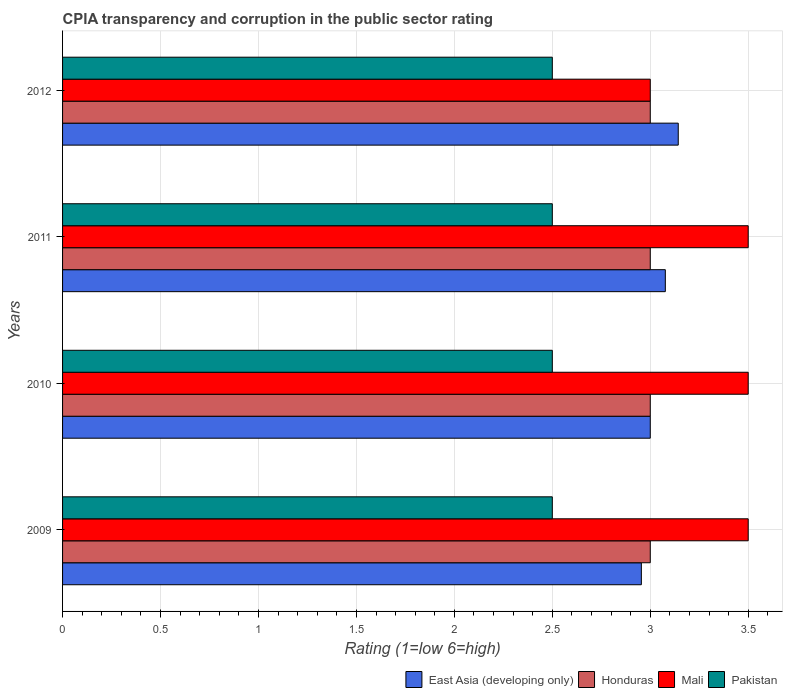How many different coloured bars are there?
Give a very brief answer. 4. Are the number of bars per tick equal to the number of legend labels?
Your response must be concise. Yes. Are the number of bars on each tick of the Y-axis equal?
Your answer should be compact. Yes. In how many cases, is the number of bars for a given year not equal to the number of legend labels?
Provide a succinct answer. 0. Across all years, what is the minimum CPIA rating in East Asia (developing only)?
Offer a terse response. 2.95. What is the difference between the CPIA rating in Honduras in 2010 and that in 2011?
Offer a very short reply. 0. What is the average CPIA rating in Mali per year?
Offer a terse response. 3.38. In how many years, is the CPIA rating in Mali greater than 0.30000000000000004 ?
Keep it short and to the point. 4. What is the ratio of the CPIA rating in Honduras in 2009 to that in 2012?
Your answer should be compact. 1. Is the difference between the CPIA rating in Pakistan in 2009 and 2011 greater than the difference between the CPIA rating in Mali in 2009 and 2011?
Provide a short and direct response. No. What is the difference between the highest and the second highest CPIA rating in Mali?
Provide a short and direct response. 0. In how many years, is the CPIA rating in East Asia (developing only) greater than the average CPIA rating in East Asia (developing only) taken over all years?
Provide a succinct answer. 2. What does the 2nd bar from the top in 2012 represents?
Make the answer very short. Mali. What does the 4th bar from the bottom in 2012 represents?
Keep it short and to the point. Pakistan. How many years are there in the graph?
Keep it short and to the point. 4. Does the graph contain any zero values?
Provide a succinct answer. No. How many legend labels are there?
Provide a short and direct response. 4. How are the legend labels stacked?
Your answer should be very brief. Horizontal. What is the title of the graph?
Give a very brief answer. CPIA transparency and corruption in the public sector rating. What is the label or title of the X-axis?
Provide a succinct answer. Rating (1=low 6=high). What is the Rating (1=low 6=high) in East Asia (developing only) in 2009?
Offer a very short reply. 2.95. What is the Rating (1=low 6=high) in Mali in 2009?
Offer a very short reply. 3.5. What is the Rating (1=low 6=high) of Pakistan in 2009?
Make the answer very short. 2.5. What is the Rating (1=low 6=high) in East Asia (developing only) in 2010?
Give a very brief answer. 3. What is the Rating (1=low 6=high) in Honduras in 2010?
Keep it short and to the point. 3. What is the Rating (1=low 6=high) in Mali in 2010?
Provide a succinct answer. 3.5. What is the Rating (1=low 6=high) in Pakistan in 2010?
Offer a terse response. 2.5. What is the Rating (1=low 6=high) of East Asia (developing only) in 2011?
Offer a terse response. 3.08. What is the Rating (1=low 6=high) of Honduras in 2011?
Ensure brevity in your answer.  3. What is the Rating (1=low 6=high) in Mali in 2011?
Your answer should be compact. 3.5. What is the Rating (1=low 6=high) of East Asia (developing only) in 2012?
Keep it short and to the point. 3.14. Across all years, what is the maximum Rating (1=low 6=high) in East Asia (developing only)?
Make the answer very short. 3.14. Across all years, what is the maximum Rating (1=low 6=high) of Honduras?
Ensure brevity in your answer.  3. Across all years, what is the minimum Rating (1=low 6=high) in East Asia (developing only)?
Make the answer very short. 2.95. Across all years, what is the minimum Rating (1=low 6=high) of Pakistan?
Provide a succinct answer. 2.5. What is the total Rating (1=low 6=high) of East Asia (developing only) in the graph?
Provide a short and direct response. 12.17. What is the total Rating (1=low 6=high) in Mali in the graph?
Ensure brevity in your answer.  13.5. What is the total Rating (1=low 6=high) in Pakistan in the graph?
Your response must be concise. 10. What is the difference between the Rating (1=low 6=high) of East Asia (developing only) in 2009 and that in 2010?
Offer a terse response. -0.05. What is the difference between the Rating (1=low 6=high) of Pakistan in 2009 and that in 2010?
Your answer should be very brief. 0. What is the difference between the Rating (1=low 6=high) in East Asia (developing only) in 2009 and that in 2011?
Ensure brevity in your answer.  -0.12. What is the difference between the Rating (1=low 6=high) in Honduras in 2009 and that in 2011?
Keep it short and to the point. 0. What is the difference between the Rating (1=low 6=high) of Mali in 2009 and that in 2011?
Make the answer very short. 0. What is the difference between the Rating (1=low 6=high) in Pakistan in 2009 and that in 2011?
Make the answer very short. 0. What is the difference between the Rating (1=low 6=high) in East Asia (developing only) in 2009 and that in 2012?
Provide a short and direct response. -0.19. What is the difference between the Rating (1=low 6=high) in Honduras in 2009 and that in 2012?
Make the answer very short. 0. What is the difference between the Rating (1=low 6=high) in Mali in 2009 and that in 2012?
Keep it short and to the point. 0.5. What is the difference between the Rating (1=low 6=high) in Pakistan in 2009 and that in 2012?
Your response must be concise. 0. What is the difference between the Rating (1=low 6=high) in East Asia (developing only) in 2010 and that in 2011?
Keep it short and to the point. -0.08. What is the difference between the Rating (1=low 6=high) of Honduras in 2010 and that in 2011?
Your response must be concise. 0. What is the difference between the Rating (1=low 6=high) in Mali in 2010 and that in 2011?
Your response must be concise. 0. What is the difference between the Rating (1=low 6=high) in East Asia (developing only) in 2010 and that in 2012?
Offer a very short reply. -0.14. What is the difference between the Rating (1=low 6=high) in Pakistan in 2010 and that in 2012?
Offer a very short reply. 0. What is the difference between the Rating (1=low 6=high) in East Asia (developing only) in 2011 and that in 2012?
Make the answer very short. -0.07. What is the difference between the Rating (1=low 6=high) in Mali in 2011 and that in 2012?
Provide a short and direct response. 0.5. What is the difference between the Rating (1=low 6=high) of Pakistan in 2011 and that in 2012?
Provide a short and direct response. 0. What is the difference between the Rating (1=low 6=high) in East Asia (developing only) in 2009 and the Rating (1=low 6=high) in Honduras in 2010?
Provide a short and direct response. -0.05. What is the difference between the Rating (1=low 6=high) of East Asia (developing only) in 2009 and the Rating (1=low 6=high) of Mali in 2010?
Your answer should be compact. -0.55. What is the difference between the Rating (1=low 6=high) in East Asia (developing only) in 2009 and the Rating (1=low 6=high) in Pakistan in 2010?
Your response must be concise. 0.45. What is the difference between the Rating (1=low 6=high) in Honduras in 2009 and the Rating (1=low 6=high) in Pakistan in 2010?
Offer a very short reply. 0.5. What is the difference between the Rating (1=low 6=high) of Mali in 2009 and the Rating (1=low 6=high) of Pakistan in 2010?
Offer a terse response. 1. What is the difference between the Rating (1=low 6=high) in East Asia (developing only) in 2009 and the Rating (1=low 6=high) in Honduras in 2011?
Offer a terse response. -0.05. What is the difference between the Rating (1=low 6=high) in East Asia (developing only) in 2009 and the Rating (1=low 6=high) in Mali in 2011?
Ensure brevity in your answer.  -0.55. What is the difference between the Rating (1=low 6=high) in East Asia (developing only) in 2009 and the Rating (1=low 6=high) in Pakistan in 2011?
Provide a succinct answer. 0.45. What is the difference between the Rating (1=low 6=high) of Honduras in 2009 and the Rating (1=low 6=high) of Mali in 2011?
Offer a terse response. -0.5. What is the difference between the Rating (1=low 6=high) of Honduras in 2009 and the Rating (1=low 6=high) of Pakistan in 2011?
Provide a short and direct response. 0.5. What is the difference between the Rating (1=low 6=high) of East Asia (developing only) in 2009 and the Rating (1=low 6=high) of Honduras in 2012?
Your answer should be compact. -0.05. What is the difference between the Rating (1=low 6=high) in East Asia (developing only) in 2009 and the Rating (1=low 6=high) in Mali in 2012?
Ensure brevity in your answer.  -0.05. What is the difference between the Rating (1=low 6=high) of East Asia (developing only) in 2009 and the Rating (1=low 6=high) of Pakistan in 2012?
Provide a succinct answer. 0.45. What is the difference between the Rating (1=low 6=high) in Honduras in 2009 and the Rating (1=low 6=high) in Mali in 2012?
Offer a very short reply. 0. What is the difference between the Rating (1=low 6=high) of Mali in 2009 and the Rating (1=low 6=high) of Pakistan in 2012?
Your answer should be very brief. 1. What is the difference between the Rating (1=low 6=high) of East Asia (developing only) in 2010 and the Rating (1=low 6=high) of Honduras in 2011?
Your answer should be compact. 0. What is the difference between the Rating (1=low 6=high) in East Asia (developing only) in 2010 and the Rating (1=low 6=high) in Mali in 2011?
Keep it short and to the point. -0.5. What is the difference between the Rating (1=low 6=high) of East Asia (developing only) in 2010 and the Rating (1=low 6=high) of Pakistan in 2011?
Ensure brevity in your answer.  0.5. What is the difference between the Rating (1=low 6=high) in Honduras in 2010 and the Rating (1=low 6=high) in Mali in 2011?
Offer a terse response. -0.5. What is the difference between the Rating (1=low 6=high) in Honduras in 2010 and the Rating (1=low 6=high) in Pakistan in 2011?
Provide a succinct answer. 0.5. What is the difference between the Rating (1=low 6=high) in Mali in 2010 and the Rating (1=low 6=high) in Pakistan in 2011?
Keep it short and to the point. 1. What is the difference between the Rating (1=low 6=high) of East Asia (developing only) in 2010 and the Rating (1=low 6=high) of Honduras in 2012?
Your answer should be compact. 0. What is the difference between the Rating (1=low 6=high) in East Asia (developing only) in 2010 and the Rating (1=low 6=high) in Mali in 2012?
Provide a short and direct response. 0. What is the difference between the Rating (1=low 6=high) of East Asia (developing only) in 2010 and the Rating (1=low 6=high) of Pakistan in 2012?
Give a very brief answer. 0.5. What is the difference between the Rating (1=low 6=high) of East Asia (developing only) in 2011 and the Rating (1=low 6=high) of Honduras in 2012?
Offer a terse response. 0.08. What is the difference between the Rating (1=low 6=high) in East Asia (developing only) in 2011 and the Rating (1=low 6=high) in Mali in 2012?
Provide a succinct answer. 0.08. What is the difference between the Rating (1=low 6=high) of East Asia (developing only) in 2011 and the Rating (1=low 6=high) of Pakistan in 2012?
Your answer should be very brief. 0.58. What is the average Rating (1=low 6=high) of East Asia (developing only) per year?
Your answer should be very brief. 3.04. What is the average Rating (1=low 6=high) of Mali per year?
Ensure brevity in your answer.  3.38. In the year 2009, what is the difference between the Rating (1=low 6=high) in East Asia (developing only) and Rating (1=low 6=high) in Honduras?
Ensure brevity in your answer.  -0.05. In the year 2009, what is the difference between the Rating (1=low 6=high) in East Asia (developing only) and Rating (1=low 6=high) in Mali?
Provide a short and direct response. -0.55. In the year 2009, what is the difference between the Rating (1=low 6=high) in East Asia (developing only) and Rating (1=low 6=high) in Pakistan?
Provide a succinct answer. 0.45. In the year 2009, what is the difference between the Rating (1=low 6=high) of Honduras and Rating (1=low 6=high) of Mali?
Your answer should be very brief. -0.5. In the year 2009, what is the difference between the Rating (1=low 6=high) of Honduras and Rating (1=low 6=high) of Pakistan?
Offer a terse response. 0.5. In the year 2010, what is the difference between the Rating (1=low 6=high) of East Asia (developing only) and Rating (1=low 6=high) of Mali?
Offer a very short reply. -0.5. In the year 2010, what is the difference between the Rating (1=low 6=high) of East Asia (developing only) and Rating (1=low 6=high) of Pakistan?
Ensure brevity in your answer.  0.5. In the year 2010, what is the difference between the Rating (1=low 6=high) of Honduras and Rating (1=low 6=high) of Mali?
Provide a short and direct response. -0.5. In the year 2010, what is the difference between the Rating (1=low 6=high) in Honduras and Rating (1=low 6=high) in Pakistan?
Provide a short and direct response. 0.5. In the year 2010, what is the difference between the Rating (1=low 6=high) in Mali and Rating (1=low 6=high) in Pakistan?
Provide a succinct answer. 1. In the year 2011, what is the difference between the Rating (1=low 6=high) of East Asia (developing only) and Rating (1=low 6=high) of Honduras?
Ensure brevity in your answer.  0.08. In the year 2011, what is the difference between the Rating (1=low 6=high) of East Asia (developing only) and Rating (1=low 6=high) of Mali?
Give a very brief answer. -0.42. In the year 2011, what is the difference between the Rating (1=low 6=high) in East Asia (developing only) and Rating (1=low 6=high) in Pakistan?
Provide a succinct answer. 0.58. In the year 2011, what is the difference between the Rating (1=low 6=high) in Honduras and Rating (1=low 6=high) in Pakistan?
Ensure brevity in your answer.  0.5. In the year 2012, what is the difference between the Rating (1=low 6=high) in East Asia (developing only) and Rating (1=low 6=high) in Honduras?
Provide a short and direct response. 0.14. In the year 2012, what is the difference between the Rating (1=low 6=high) in East Asia (developing only) and Rating (1=low 6=high) in Mali?
Your answer should be compact. 0.14. In the year 2012, what is the difference between the Rating (1=low 6=high) in East Asia (developing only) and Rating (1=low 6=high) in Pakistan?
Your answer should be very brief. 0.64. In the year 2012, what is the difference between the Rating (1=low 6=high) of Honduras and Rating (1=low 6=high) of Pakistan?
Keep it short and to the point. 0.5. What is the ratio of the Rating (1=low 6=high) in Honduras in 2009 to that in 2010?
Give a very brief answer. 1. What is the ratio of the Rating (1=low 6=high) in Pakistan in 2009 to that in 2010?
Your answer should be compact. 1. What is the ratio of the Rating (1=low 6=high) of East Asia (developing only) in 2009 to that in 2011?
Make the answer very short. 0.96. What is the ratio of the Rating (1=low 6=high) of Honduras in 2009 to that in 2011?
Your answer should be compact. 1. What is the ratio of the Rating (1=low 6=high) in East Asia (developing only) in 2009 to that in 2012?
Provide a short and direct response. 0.94. What is the ratio of the Rating (1=low 6=high) of Honduras in 2009 to that in 2012?
Make the answer very short. 1. What is the ratio of the Rating (1=low 6=high) of Pakistan in 2009 to that in 2012?
Keep it short and to the point. 1. What is the ratio of the Rating (1=low 6=high) in East Asia (developing only) in 2010 to that in 2011?
Provide a short and direct response. 0.97. What is the ratio of the Rating (1=low 6=high) in East Asia (developing only) in 2010 to that in 2012?
Keep it short and to the point. 0.95. What is the ratio of the Rating (1=low 6=high) in Honduras in 2010 to that in 2012?
Give a very brief answer. 1. What is the ratio of the Rating (1=low 6=high) in Mali in 2010 to that in 2012?
Your answer should be very brief. 1.17. What is the ratio of the Rating (1=low 6=high) in Pakistan in 2010 to that in 2012?
Offer a terse response. 1. What is the ratio of the Rating (1=low 6=high) of East Asia (developing only) in 2011 to that in 2012?
Your response must be concise. 0.98. What is the ratio of the Rating (1=low 6=high) of Mali in 2011 to that in 2012?
Your response must be concise. 1.17. What is the difference between the highest and the second highest Rating (1=low 6=high) of East Asia (developing only)?
Your answer should be compact. 0.07. What is the difference between the highest and the second highest Rating (1=low 6=high) of Mali?
Provide a short and direct response. 0. What is the difference between the highest and the second highest Rating (1=low 6=high) in Pakistan?
Provide a short and direct response. 0. What is the difference between the highest and the lowest Rating (1=low 6=high) in East Asia (developing only)?
Your response must be concise. 0.19. 